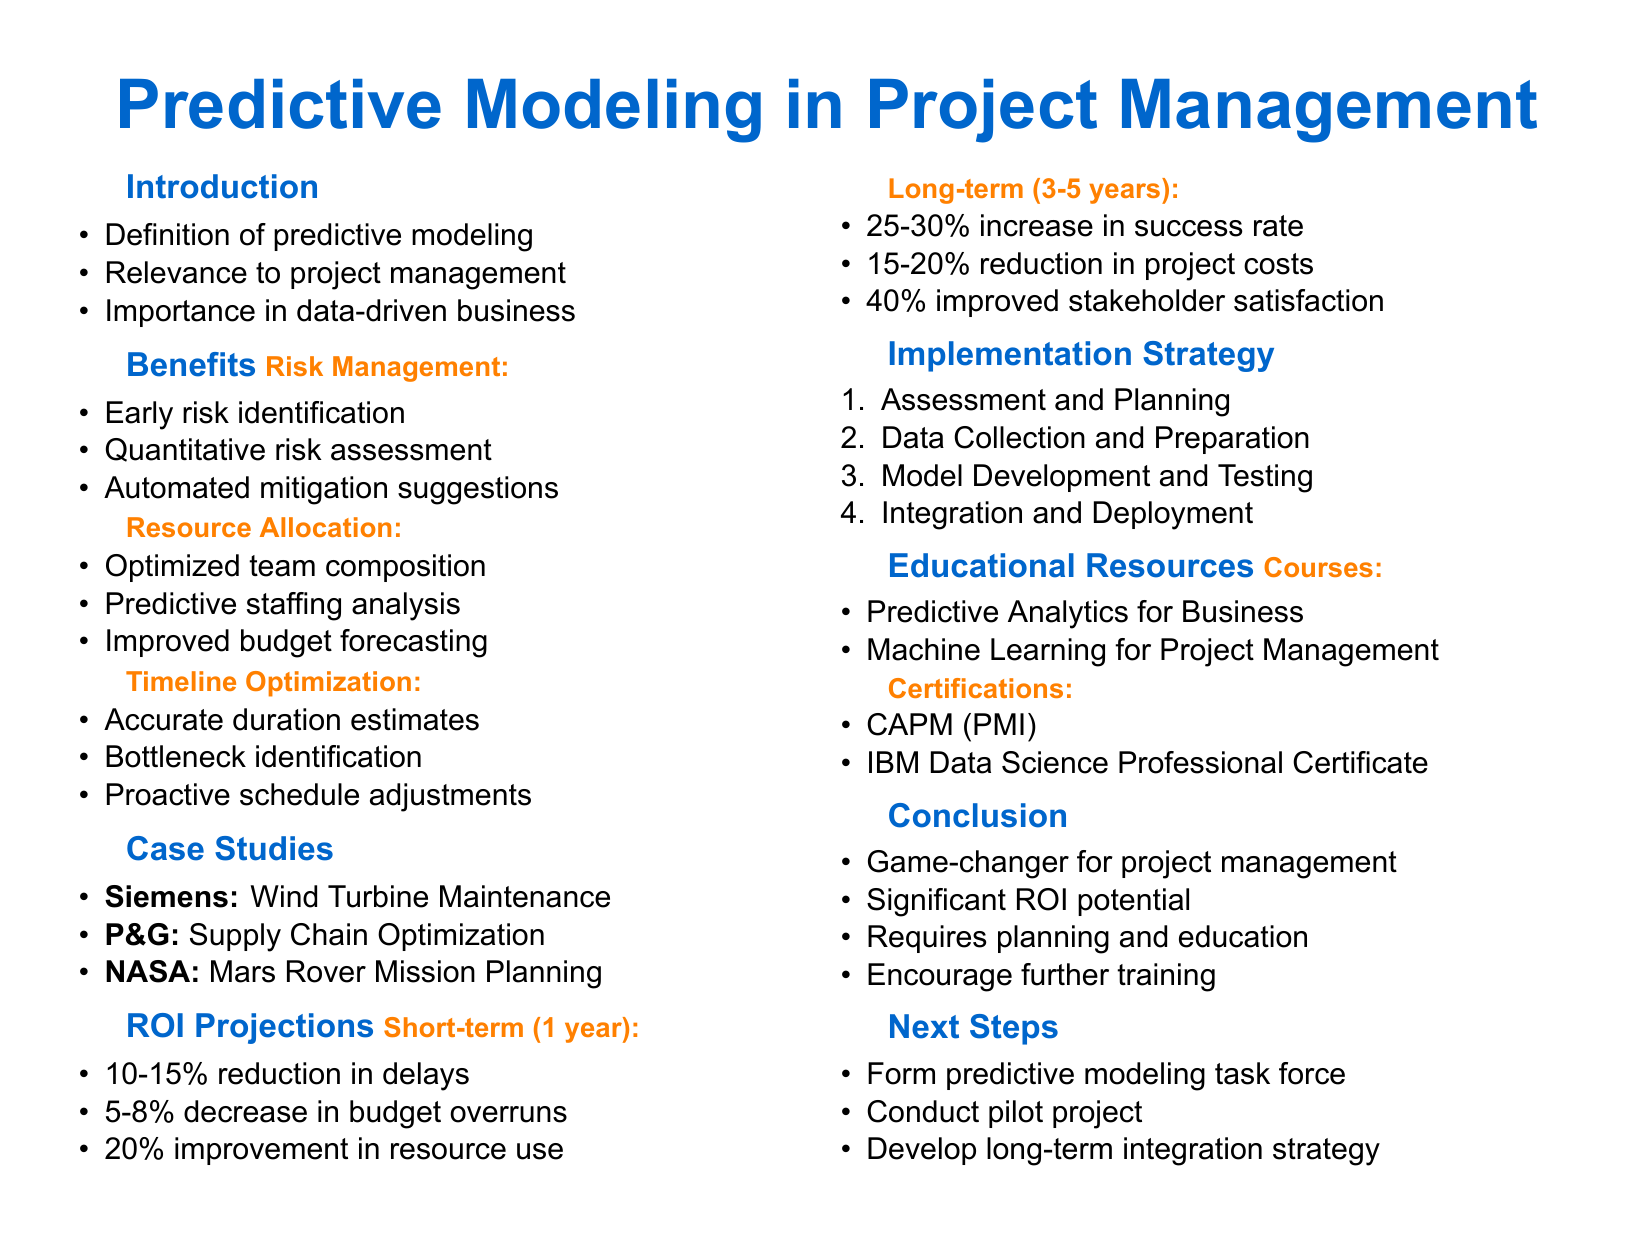What is the title of the presentation? The title of the presentation is stated at the beginning of the document.
Answer: The Power of Predictive Modeling in Project Management Which company achieved a 30% reduction in downtime? The case studies mention several companies; the one with a 30% reduction in downtime is Siemens.
Answer: Siemens What percentage increase in successful project completions is expected in the long-term projections? The long-term ROI projections specify the expected benefits for project completions.
Answer: 25-30% What predictive model did NASA use for the Mars Rover Mission Planning? The document indicates which predictive models were used in each case study.
Answer: Monte Carlo simulations for risk assessment What is the duration of the course "Machine Learning for Project Management"? The duration of each course listed in the educational resources section is included in the document.
Answer: 8 weeks What is one expected short-term benefit mentioned in the document? The short-term benefits are listed in the ROI projections, and one of them is specifically mentioned.
Answer: 10-15% reduction in project delays What is the first phase in the implementation strategy? The implementation strategy lists activities divided by phases. The first phase can be directly found in this list.
Answer: Assessment and Planning What type of certification does the Project Management Institute (PMI) offer? The educational resources mention different certifications, including the one offered by PMI.
Answer: Certified Associate in Project Management (CAPM) 